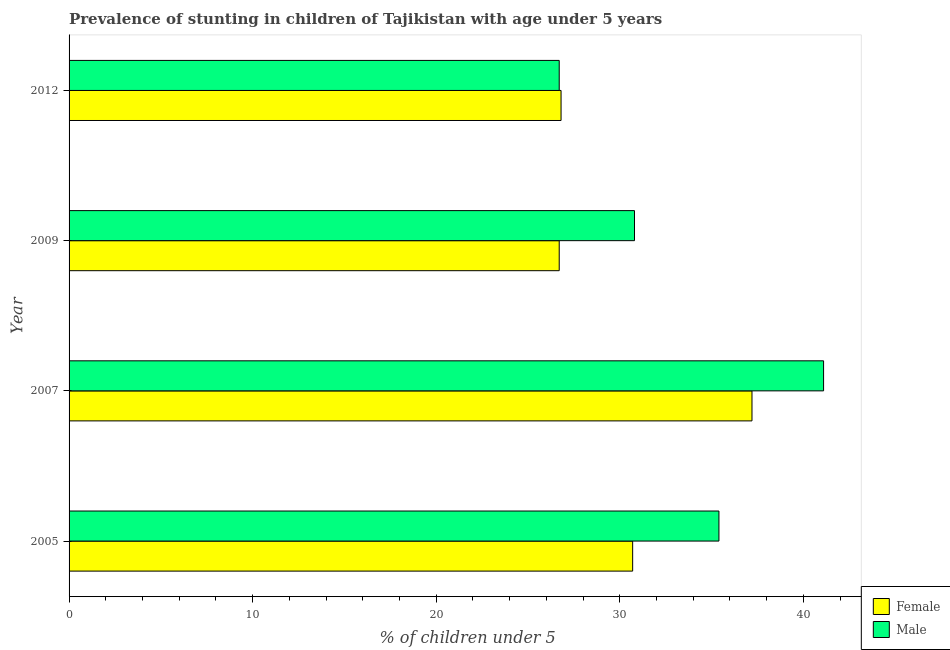How many bars are there on the 3rd tick from the top?
Offer a terse response. 2. How many bars are there on the 3rd tick from the bottom?
Offer a very short reply. 2. What is the label of the 4th group of bars from the top?
Provide a succinct answer. 2005. In how many cases, is the number of bars for a given year not equal to the number of legend labels?
Offer a terse response. 0. What is the percentage of stunted female children in 2009?
Provide a succinct answer. 26.7. Across all years, what is the maximum percentage of stunted male children?
Your answer should be very brief. 41.1. Across all years, what is the minimum percentage of stunted female children?
Your answer should be compact. 26.7. In which year was the percentage of stunted female children minimum?
Offer a very short reply. 2009. What is the total percentage of stunted male children in the graph?
Offer a terse response. 134. What is the difference between the percentage of stunted female children in 2012 and the percentage of stunted male children in 2007?
Your answer should be very brief. -14.3. What is the average percentage of stunted male children per year?
Your answer should be compact. 33.5. In the year 2007, what is the difference between the percentage of stunted male children and percentage of stunted female children?
Ensure brevity in your answer.  3.9. In how many years, is the percentage of stunted male children greater than 4 %?
Offer a terse response. 4. What is the ratio of the percentage of stunted female children in 2007 to that in 2009?
Make the answer very short. 1.39. Is the percentage of stunted female children in 2005 less than that in 2012?
Your response must be concise. No. Is the difference between the percentage of stunted male children in 2005 and 2012 greater than the difference between the percentage of stunted female children in 2005 and 2012?
Ensure brevity in your answer.  Yes. What is the difference between the highest and the lowest percentage of stunted female children?
Your response must be concise. 10.5. Is the sum of the percentage of stunted male children in 2005 and 2009 greater than the maximum percentage of stunted female children across all years?
Give a very brief answer. Yes. What does the 1st bar from the bottom in 2012 represents?
Ensure brevity in your answer.  Female. How many bars are there?
Provide a succinct answer. 8. Are all the bars in the graph horizontal?
Your response must be concise. Yes. How many years are there in the graph?
Offer a very short reply. 4. What is the difference between two consecutive major ticks on the X-axis?
Provide a succinct answer. 10. Are the values on the major ticks of X-axis written in scientific E-notation?
Provide a succinct answer. No. Does the graph contain any zero values?
Keep it short and to the point. No. Where does the legend appear in the graph?
Provide a succinct answer. Bottom right. How are the legend labels stacked?
Provide a short and direct response. Vertical. What is the title of the graph?
Give a very brief answer. Prevalence of stunting in children of Tajikistan with age under 5 years. Does "Export" appear as one of the legend labels in the graph?
Ensure brevity in your answer.  No. What is the label or title of the X-axis?
Ensure brevity in your answer.   % of children under 5. What is the label or title of the Y-axis?
Ensure brevity in your answer.  Year. What is the  % of children under 5 of Female in 2005?
Make the answer very short. 30.7. What is the  % of children under 5 of Male in 2005?
Offer a terse response. 35.4. What is the  % of children under 5 of Female in 2007?
Make the answer very short. 37.2. What is the  % of children under 5 of Male in 2007?
Provide a succinct answer. 41.1. What is the  % of children under 5 in Female in 2009?
Offer a terse response. 26.7. What is the  % of children under 5 in Male in 2009?
Keep it short and to the point. 30.8. What is the  % of children under 5 in Female in 2012?
Provide a succinct answer. 26.8. What is the  % of children under 5 in Male in 2012?
Provide a short and direct response. 26.7. Across all years, what is the maximum  % of children under 5 of Female?
Ensure brevity in your answer.  37.2. Across all years, what is the maximum  % of children under 5 of Male?
Provide a succinct answer. 41.1. Across all years, what is the minimum  % of children under 5 of Female?
Provide a succinct answer. 26.7. Across all years, what is the minimum  % of children under 5 in Male?
Provide a succinct answer. 26.7. What is the total  % of children under 5 in Female in the graph?
Your response must be concise. 121.4. What is the total  % of children under 5 of Male in the graph?
Keep it short and to the point. 134. What is the difference between the  % of children under 5 of Male in 2005 and that in 2007?
Make the answer very short. -5.7. What is the difference between the  % of children under 5 of Female in 2005 and that in 2012?
Give a very brief answer. 3.9. What is the difference between the  % of children under 5 in Female in 2007 and that in 2012?
Your response must be concise. 10.4. What is the difference between the  % of children under 5 in Male in 2007 and that in 2012?
Your answer should be very brief. 14.4. What is the difference between the  % of children under 5 of Female in 2009 and that in 2012?
Keep it short and to the point. -0.1. What is the difference between the  % of children under 5 of Female in 2005 and the  % of children under 5 of Male in 2007?
Ensure brevity in your answer.  -10.4. What is the difference between the  % of children under 5 in Female in 2005 and the  % of children under 5 in Male in 2009?
Offer a terse response. -0.1. What is the difference between the  % of children under 5 of Female in 2005 and the  % of children under 5 of Male in 2012?
Ensure brevity in your answer.  4. What is the difference between the  % of children under 5 in Female in 2007 and the  % of children under 5 in Male in 2009?
Offer a very short reply. 6.4. What is the difference between the  % of children under 5 in Female in 2009 and the  % of children under 5 in Male in 2012?
Give a very brief answer. 0. What is the average  % of children under 5 of Female per year?
Provide a succinct answer. 30.35. What is the average  % of children under 5 of Male per year?
Provide a short and direct response. 33.5. In the year 2005, what is the difference between the  % of children under 5 of Female and  % of children under 5 of Male?
Provide a short and direct response. -4.7. In the year 2007, what is the difference between the  % of children under 5 in Female and  % of children under 5 in Male?
Provide a succinct answer. -3.9. In the year 2009, what is the difference between the  % of children under 5 of Female and  % of children under 5 of Male?
Keep it short and to the point. -4.1. In the year 2012, what is the difference between the  % of children under 5 in Female and  % of children under 5 in Male?
Your response must be concise. 0.1. What is the ratio of the  % of children under 5 of Female in 2005 to that in 2007?
Provide a succinct answer. 0.83. What is the ratio of the  % of children under 5 of Male in 2005 to that in 2007?
Offer a very short reply. 0.86. What is the ratio of the  % of children under 5 in Female in 2005 to that in 2009?
Provide a short and direct response. 1.15. What is the ratio of the  % of children under 5 in Male in 2005 to that in 2009?
Provide a short and direct response. 1.15. What is the ratio of the  % of children under 5 of Female in 2005 to that in 2012?
Your answer should be compact. 1.15. What is the ratio of the  % of children under 5 of Male in 2005 to that in 2012?
Give a very brief answer. 1.33. What is the ratio of the  % of children under 5 in Female in 2007 to that in 2009?
Offer a very short reply. 1.39. What is the ratio of the  % of children under 5 in Male in 2007 to that in 2009?
Ensure brevity in your answer.  1.33. What is the ratio of the  % of children under 5 of Female in 2007 to that in 2012?
Keep it short and to the point. 1.39. What is the ratio of the  % of children under 5 in Male in 2007 to that in 2012?
Provide a succinct answer. 1.54. What is the ratio of the  % of children under 5 of Female in 2009 to that in 2012?
Provide a short and direct response. 1. What is the ratio of the  % of children under 5 in Male in 2009 to that in 2012?
Provide a succinct answer. 1.15. What is the difference between the highest and the second highest  % of children under 5 in Female?
Ensure brevity in your answer.  6.5. What is the difference between the highest and the second highest  % of children under 5 of Male?
Your answer should be compact. 5.7. 